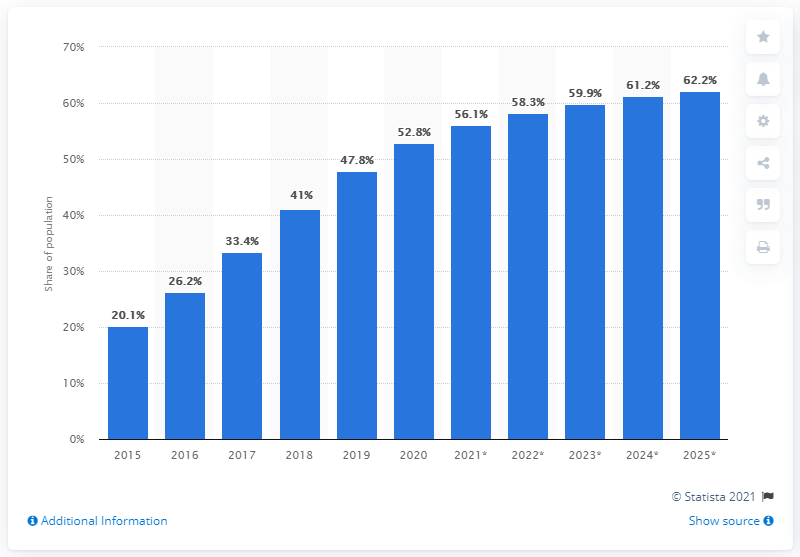Mention a couple of crucial points in this snapshot. By 2025, it is projected that 62.2% of South Africans will be using mobile devices. 